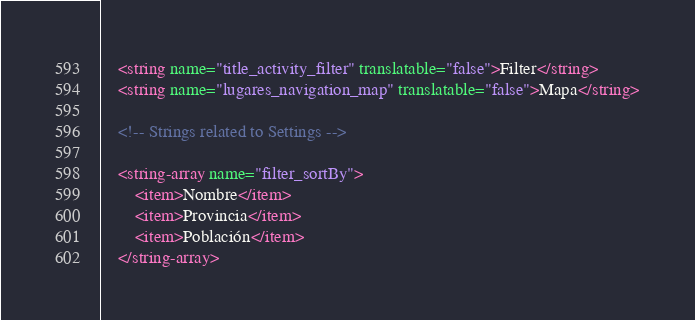<code> <loc_0><loc_0><loc_500><loc_500><_XML_>    <string name="title_activity_filter" translatable="false">Filter</string>
    <string name="lugares_navigation_map" translatable="false">Mapa</string>

    <!-- Strings related to Settings -->

    <string-array name="filter_sortBy">
        <item>Nombre</item>
        <item>Provincia</item>
        <item>Población</item>
    </string-array></code> 